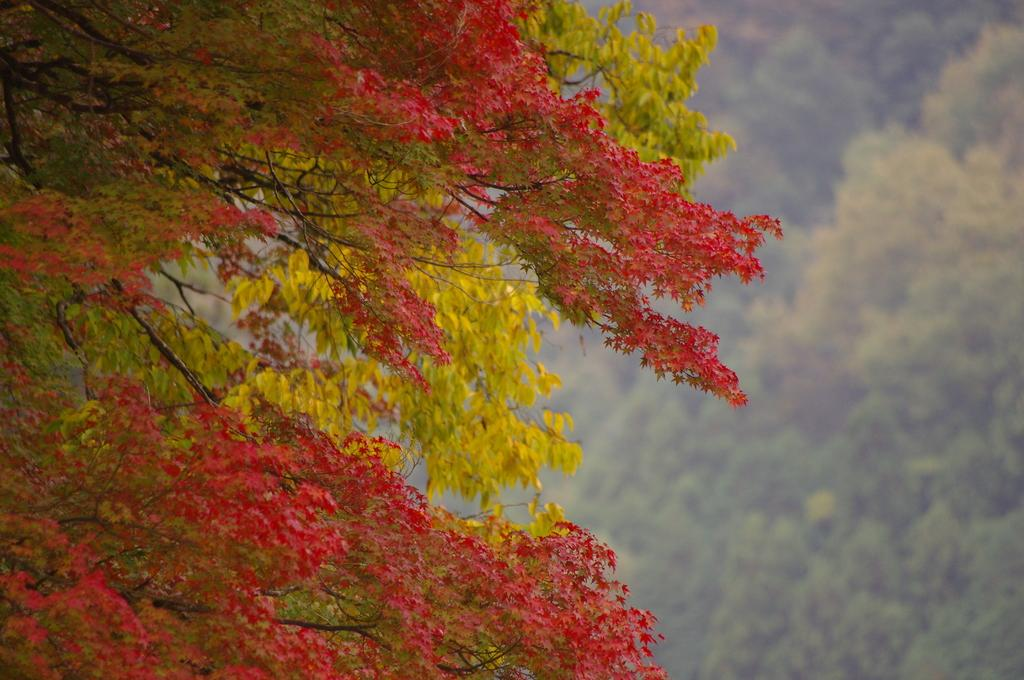What is visible in the foreground of the image? There are trees in the foreground of the image. What is visible in the background of the image? There are trees in the background of the image. What type of cracker is the maid holding in the image? There is no maid or cracker present in the image; it only features trees in the foreground and background. 